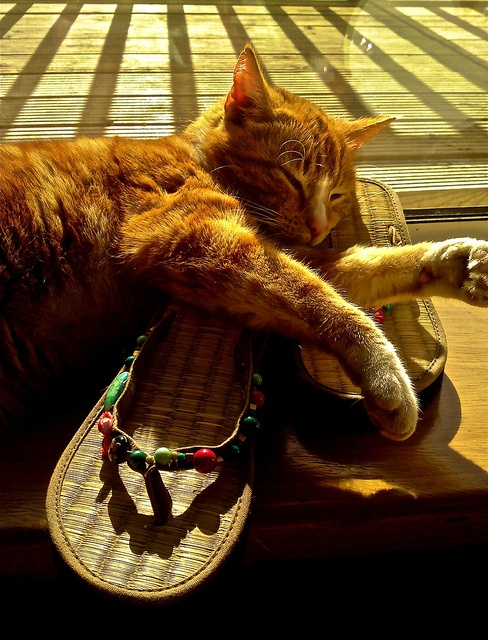Describe the objects in this image and their specific colors. I can see a cat in olive, black, maroon, brown, and orange tones in this image. 